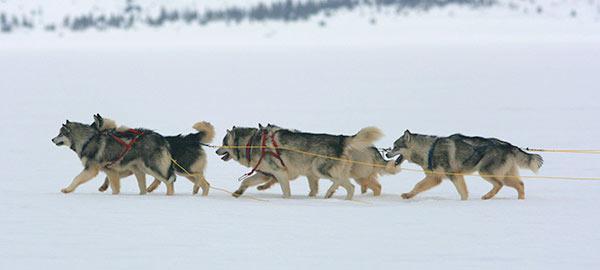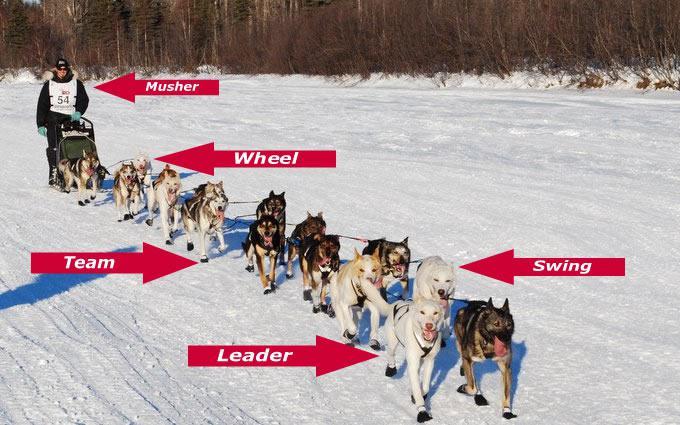The first image is the image on the left, the second image is the image on the right. For the images shown, is this caption "At least one of the teams is exactly six dogs." true? Answer yes or no. No. The first image is the image on the left, the second image is the image on the right. Analyze the images presented: Is the assertion "In one image a team of sled dogs are pulling a person to the left." valid? Answer yes or no. No. 